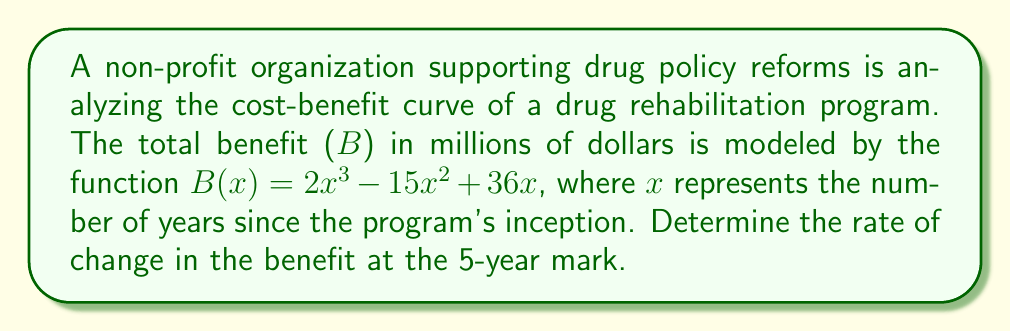Can you solve this math problem? To find the rate of change in the benefit at the 5-year mark, we need to calculate the derivative of the benefit function B(x) and evaluate it at x = 5.

Step 1: Find the derivative of B(x).
$$B(x) = 2x^3 - 15x^2 + 36x$$
$$B'(x) = 6x^2 - 30x + 36$$

Step 2: Evaluate B'(x) at x = 5.
$$B'(5) = 6(5)^2 - 30(5) + 36$$
$$B'(5) = 6(25) - 150 + 36$$
$$B'(5) = 150 - 150 + 36$$
$$B'(5) = 36$$

The rate of change in the benefit at the 5-year mark is 36 million dollars per year.
Answer: $36$ million dollars per year 